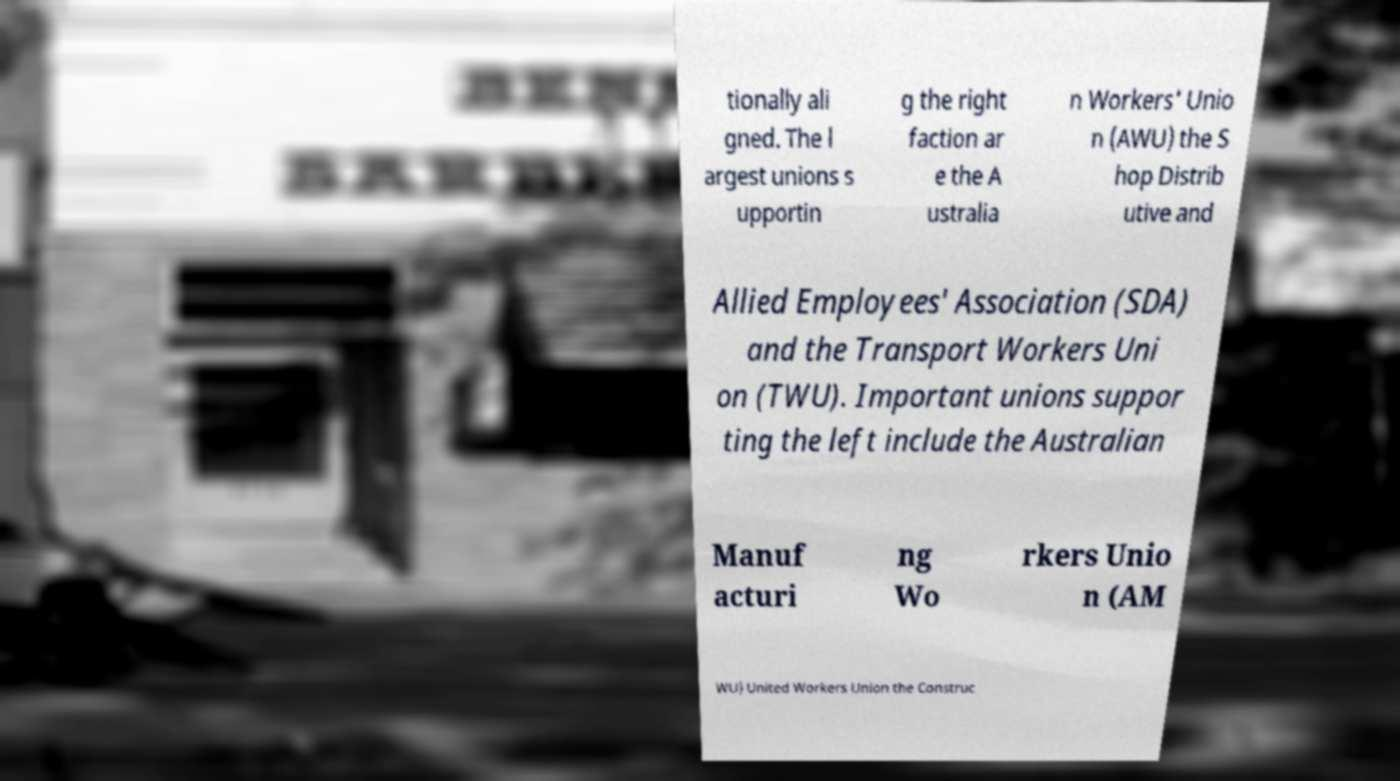What messages or text are displayed in this image? I need them in a readable, typed format. tionally ali gned. The l argest unions s upportin g the right faction ar e the A ustralia n Workers' Unio n (AWU) the S hop Distrib utive and Allied Employees' Association (SDA) and the Transport Workers Uni on (TWU). Important unions suppor ting the left include the Australian Manuf acturi ng Wo rkers Unio n (AM WU) United Workers Union the Construc 